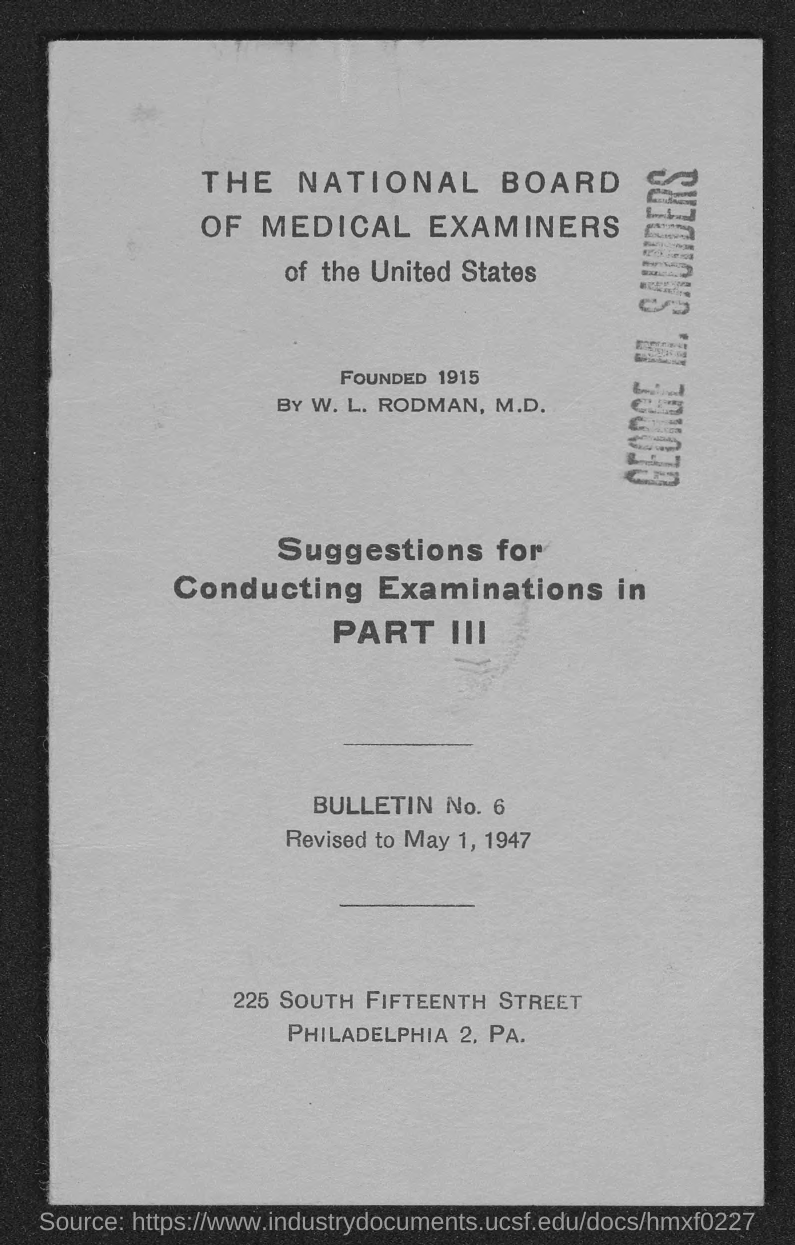List a handful of essential elements in this visual. The National Board of Medical Examiners of the United States was founded in 1915. 